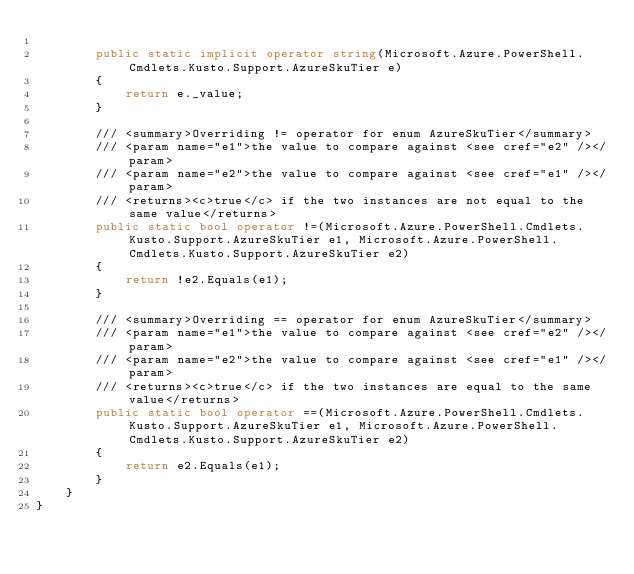<code> <loc_0><loc_0><loc_500><loc_500><_C#_>
        public static implicit operator string(Microsoft.Azure.PowerShell.Cmdlets.Kusto.Support.AzureSkuTier e)
        {
            return e._value;
        }

        /// <summary>Overriding != operator for enum AzureSkuTier</summary>
        /// <param name="e1">the value to compare against <see cref="e2" /></param>
        /// <param name="e2">the value to compare against <see cref="e1" /></param>
        /// <returns><c>true</c> if the two instances are not equal to the same value</returns>
        public static bool operator !=(Microsoft.Azure.PowerShell.Cmdlets.Kusto.Support.AzureSkuTier e1, Microsoft.Azure.PowerShell.Cmdlets.Kusto.Support.AzureSkuTier e2)
        {
            return !e2.Equals(e1);
        }

        /// <summary>Overriding == operator for enum AzureSkuTier</summary>
        /// <param name="e1">the value to compare against <see cref="e2" /></param>
        /// <param name="e2">the value to compare against <see cref="e1" /></param>
        /// <returns><c>true</c> if the two instances are equal to the same value</returns>
        public static bool operator ==(Microsoft.Azure.PowerShell.Cmdlets.Kusto.Support.AzureSkuTier e1, Microsoft.Azure.PowerShell.Cmdlets.Kusto.Support.AzureSkuTier e2)
        {
            return e2.Equals(e1);
        }
    }
}</code> 